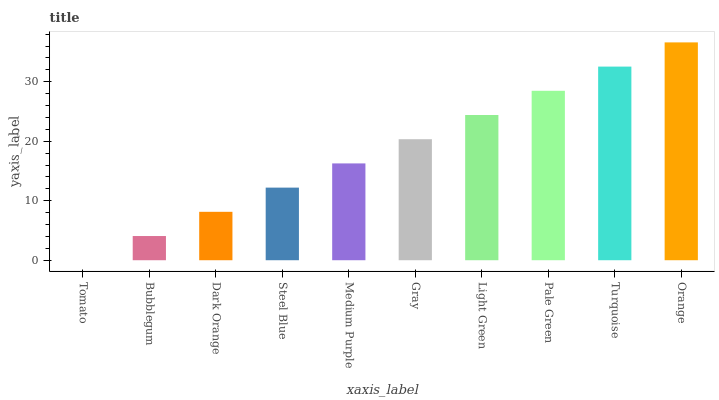Is Bubblegum the minimum?
Answer yes or no. No. Is Bubblegum the maximum?
Answer yes or no. No. Is Bubblegum greater than Tomato?
Answer yes or no. Yes. Is Tomato less than Bubblegum?
Answer yes or no. Yes. Is Tomato greater than Bubblegum?
Answer yes or no. No. Is Bubblegum less than Tomato?
Answer yes or no. No. Is Gray the high median?
Answer yes or no. Yes. Is Medium Purple the low median?
Answer yes or no. Yes. Is Medium Purple the high median?
Answer yes or no. No. Is Steel Blue the low median?
Answer yes or no. No. 